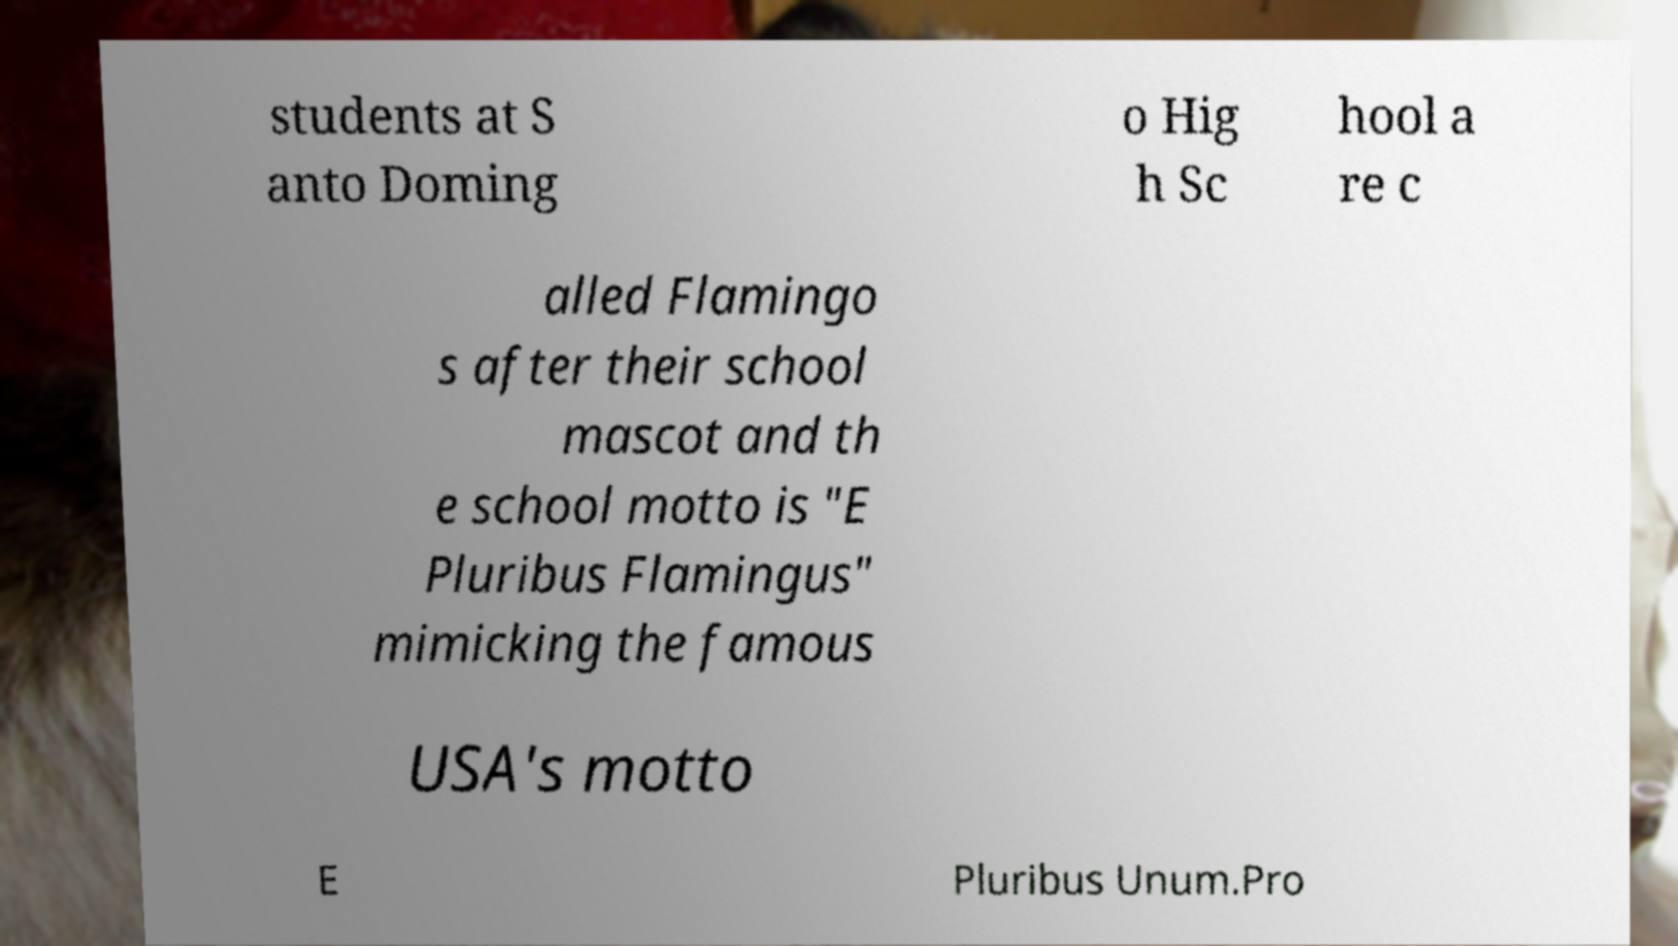I need the written content from this picture converted into text. Can you do that? students at S anto Doming o Hig h Sc hool a re c alled Flamingo s after their school mascot and th e school motto is "E Pluribus Flamingus" mimicking the famous USA's motto E Pluribus Unum.Pro 